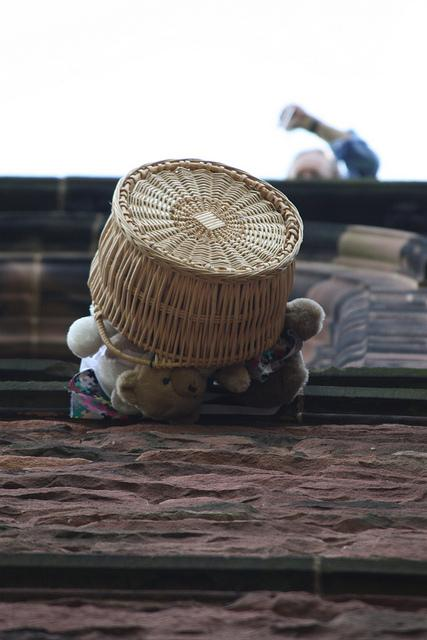What is the wicker basket covering on top of?

Choices:
A) fruits
B) head
C) teddy bears
D) vegetables teddy bears 